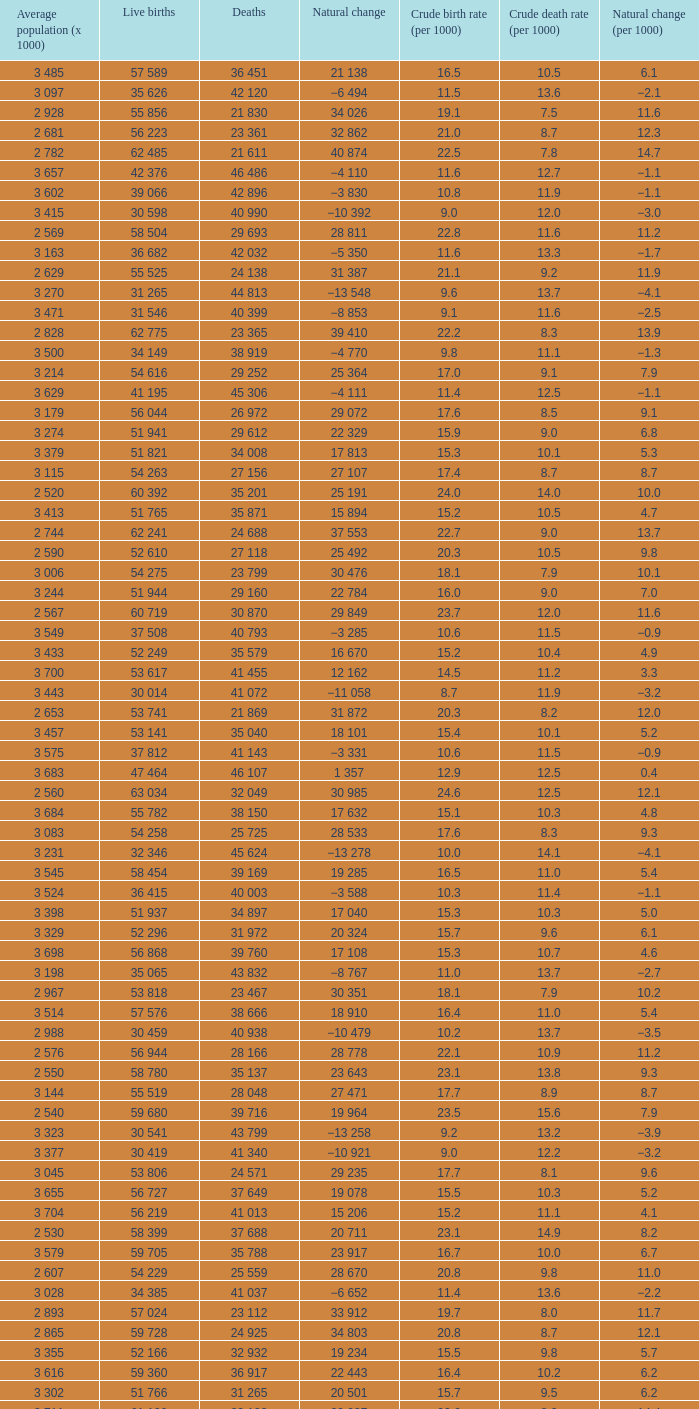Which Live births have a Natural change (per 1000) of 12.0? 53 741. 